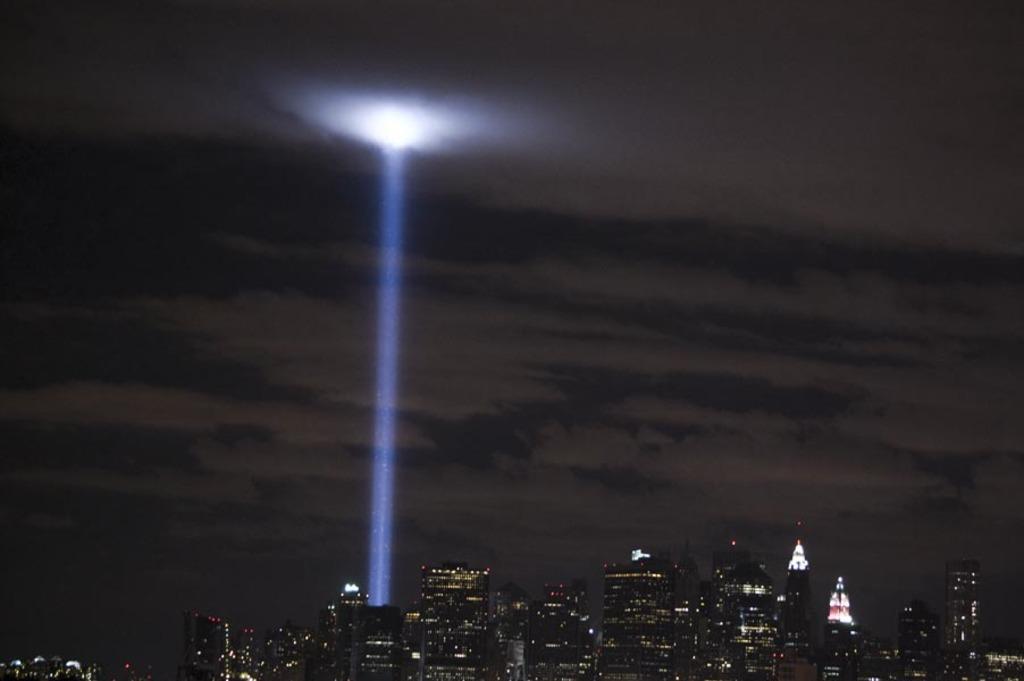Could you give a brief overview of what you see in this image? This image consists of many buildings and skyscrapers. In the middle, there is a light ray. At the top, there are clouds in the sky. 